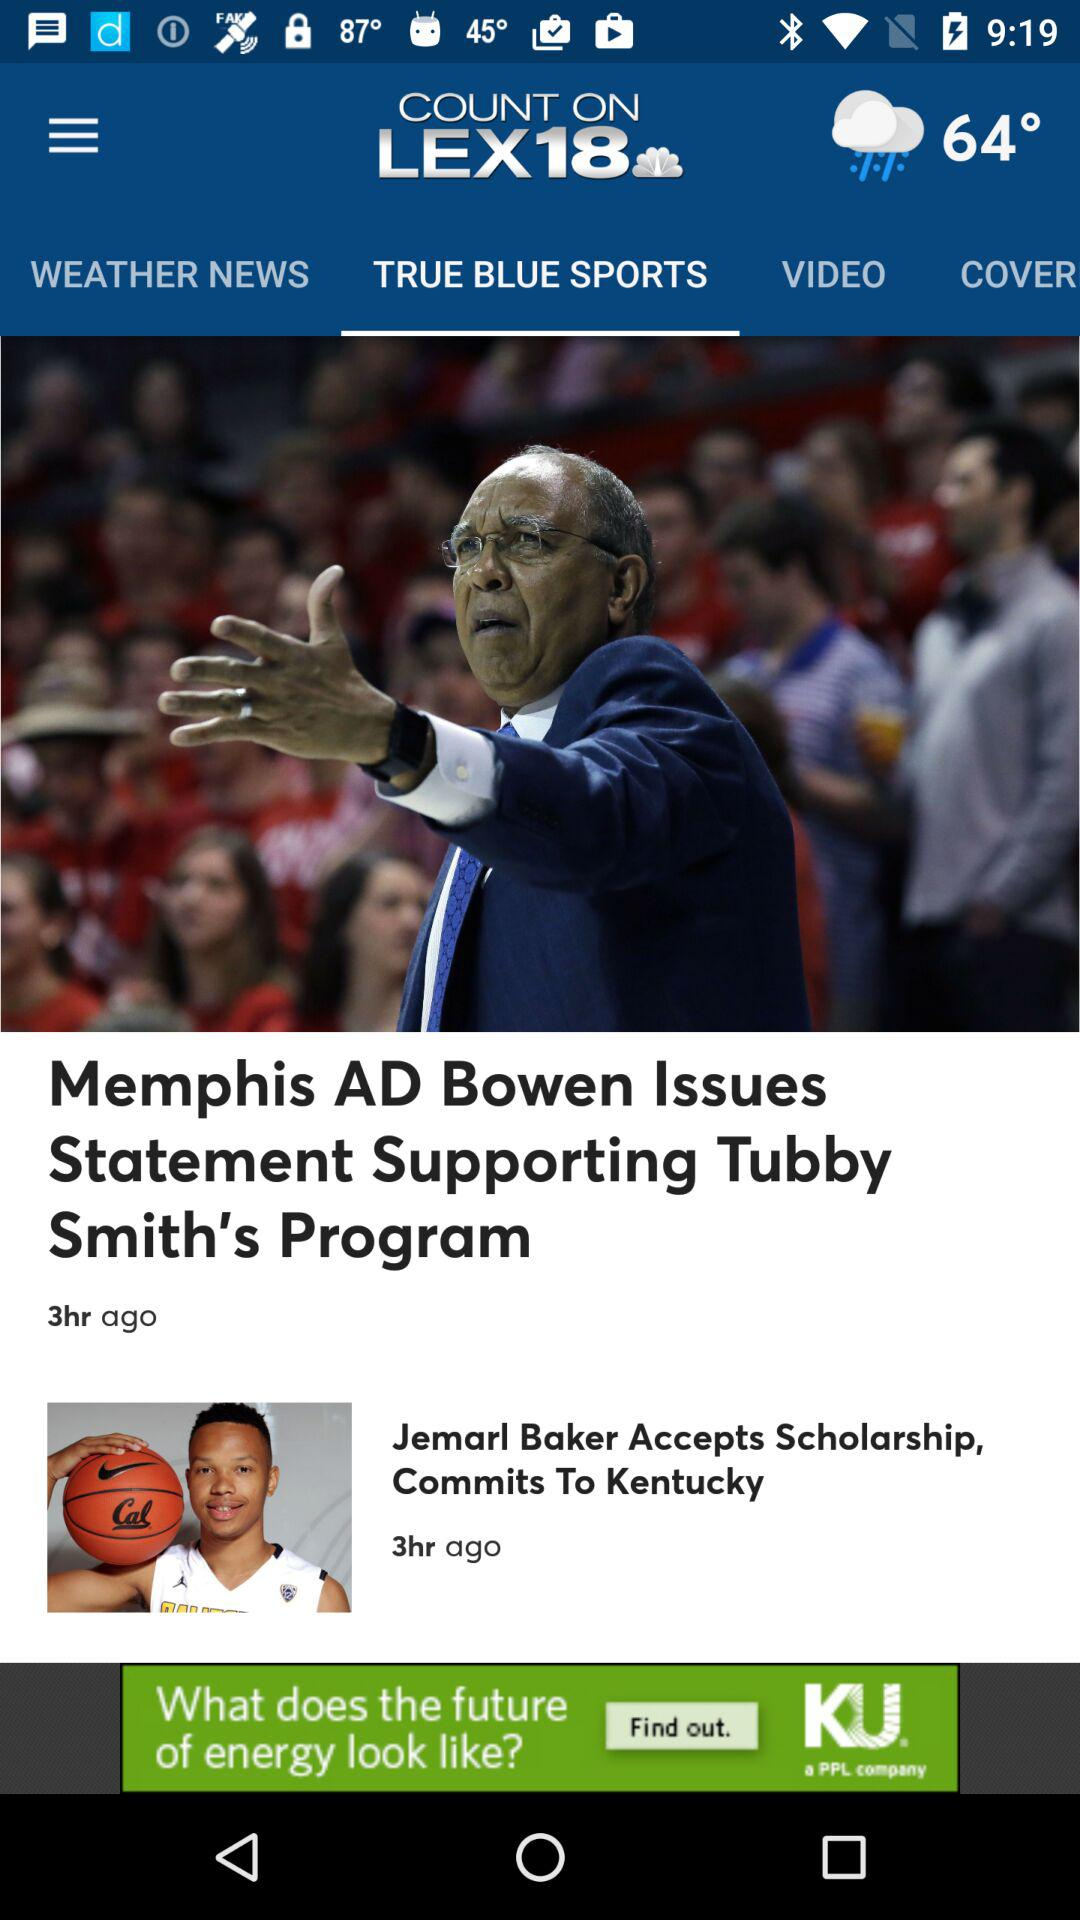What is the temperature shown on the screen? The temperature shown on the screen is 64°. 